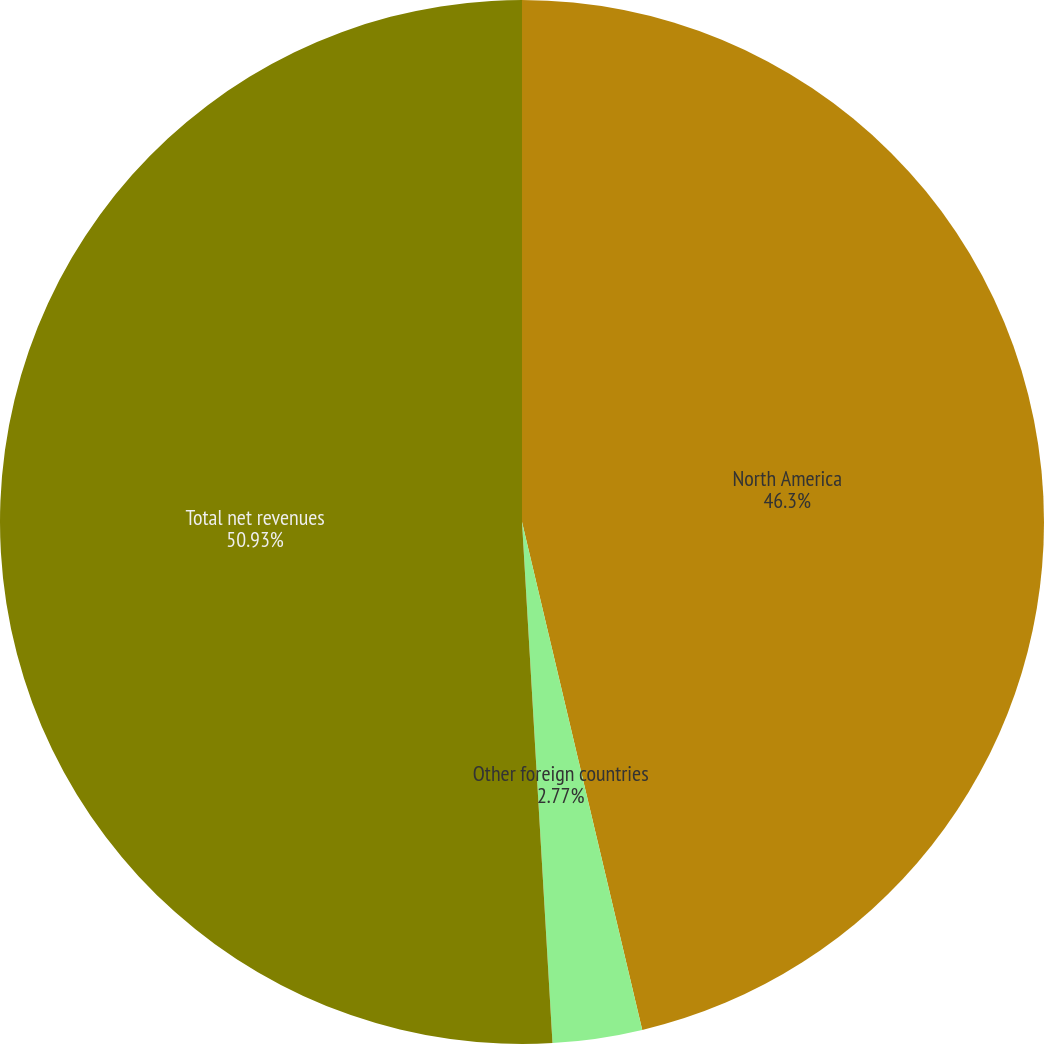Convert chart. <chart><loc_0><loc_0><loc_500><loc_500><pie_chart><fcel>North America<fcel>Other foreign countries<fcel>Total net revenues<nl><fcel>46.3%<fcel>2.77%<fcel>50.93%<nl></chart> 